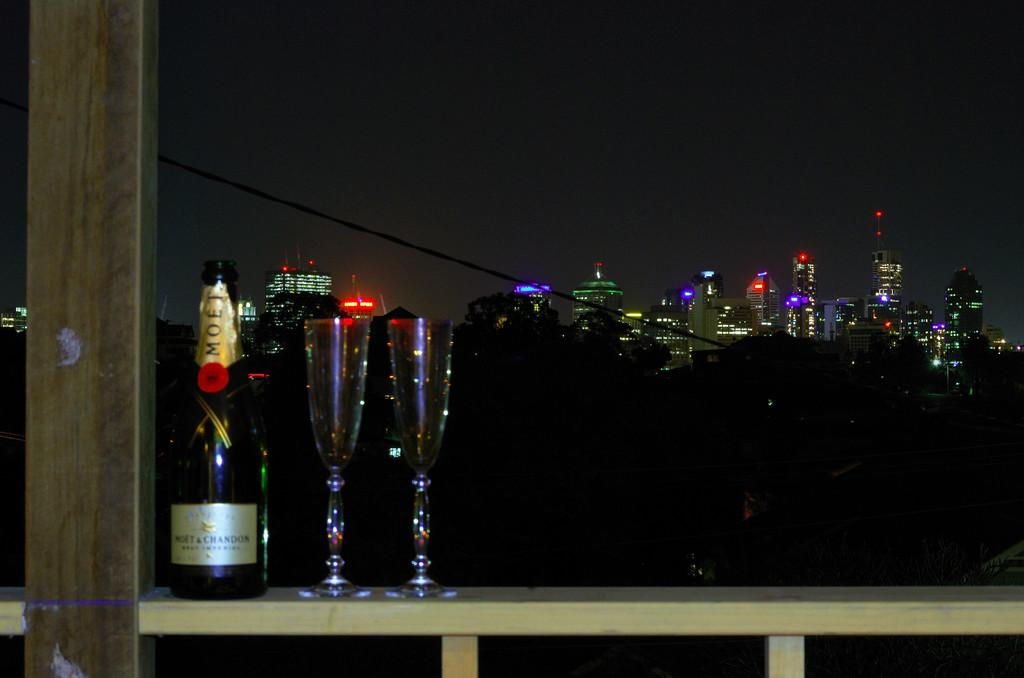<image>
Offer a succinct explanation of the picture presented. the name Chandon is on the front of some wine 